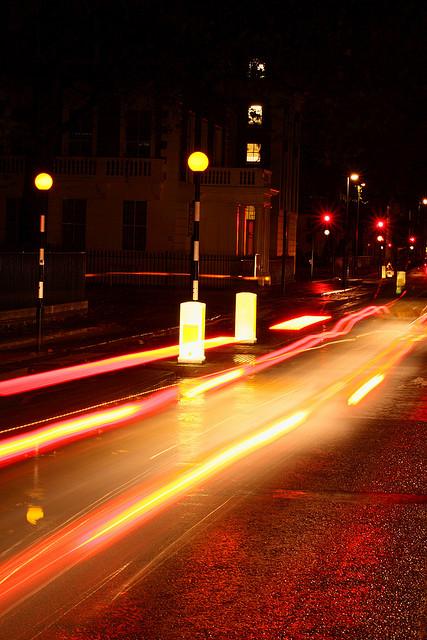Is it daytime?
Quick response, please. No. Was this a long exposure picture?
Answer briefly. Yes. Are any streetlights on?
Answer briefly. Yes. 